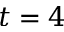Convert formula to latex. <formula><loc_0><loc_0><loc_500><loc_500>t = 4</formula> 